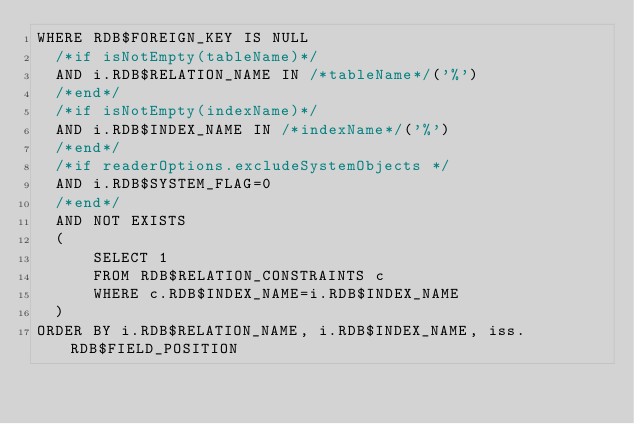<code> <loc_0><loc_0><loc_500><loc_500><_SQL_>WHERE RDB$FOREIGN_KEY IS NULL
  /*if isNotEmpty(tableName)*/
  AND i.RDB$RELATION_NAME IN /*tableName*/('%')
  /*end*/
  /*if isNotEmpty(indexName)*/
  AND i.RDB$INDEX_NAME IN /*indexName*/('%')
  /*end*/
  /*if readerOptions.excludeSystemObjects */
  AND i.RDB$SYSTEM_FLAG=0
  /*end*/
  AND NOT EXISTS
  (
      SELECT 1
      FROM RDB$RELATION_CONSTRAINTS c
      WHERE c.RDB$INDEX_NAME=i.RDB$INDEX_NAME
  )
ORDER BY i.RDB$RELATION_NAME, i.RDB$INDEX_NAME, iss.RDB$FIELD_POSITION
</code> 